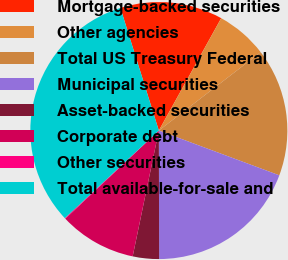Convert chart to OTSL. <chart><loc_0><loc_0><loc_500><loc_500><pie_chart><fcel>Mortgage-backed securities<fcel>Other agencies<fcel>Total US Treasury Federal<fcel>Municipal securities<fcel>Asset-backed securities<fcel>Corporate debt<fcel>Other securities<fcel>Total available-for-sale and<nl><fcel>12.9%<fcel>6.5%<fcel>16.1%<fcel>19.3%<fcel>3.3%<fcel>9.7%<fcel>0.1%<fcel>32.1%<nl></chart> 